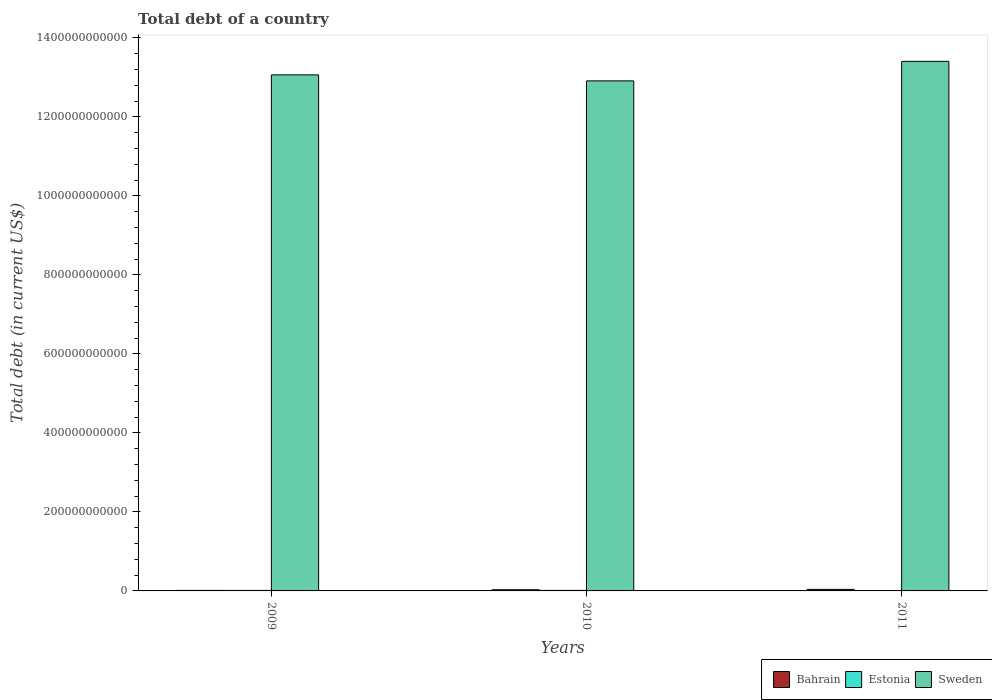How many bars are there on the 2nd tick from the right?
Provide a short and direct response. 3. What is the label of the 3rd group of bars from the left?
Ensure brevity in your answer.  2011. In how many cases, is the number of bars for a given year not equal to the number of legend labels?
Keep it short and to the point. 0. What is the debt in Sweden in 2010?
Make the answer very short. 1.29e+12. Across all years, what is the maximum debt in Estonia?
Offer a terse response. 1.31e+09. Across all years, what is the minimum debt in Estonia?
Ensure brevity in your answer.  1.08e+09. What is the total debt in Bahrain in the graph?
Give a very brief answer. 8.17e+09. What is the difference between the debt in Sweden in 2009 and that in 2011?
Ensure brevity in your answer.  -3.42e+1. What is the difference between the debt in Bahrain in 2011 and the debt in Sweden in 2009?
Keep it short and to the point. -1.30e+12. What is the average debt in Bahrain per year?
Your response must be concise. 2.72e+09. In the year 2009, what is the difference between the debt in Sweden and debt in Estonia?
Your response must be concise. 1.30e+12. In how many years, is the debt in Bahrain greater than 400000000000 US$?
Ensure brevity in your answer.  0. What is the ratio of the debt in Sweden in 2009 to that in 2011?
Ensure brevity in your answer.  0.97. Is the debt in Sweden in 2010 less than that in 2011?
Your answer should be very brief. Yes. Is the difference between the debt in Sweden in 2010 and 2011 greater than the difference between the debt in Estonia in 2010 and 2011?
Your answer should be very brief. No. What is the difference between the highest and the second highest debt in Bahrain?
Your answer should be very brief. 9.58e+08. What is the difference between the highest and the lowest debt in Bahrain?
Your answer should be compact. 2.54e+09. What does the 3rd bar from the right in 2009 represents?
Keep it short and to the point. Bahrain. How many bars are there?
Make the answer very short. 9. Are all the bars in the graph horizontal?
Provide a short and direct response. No. What is the difference between two consecutive major ticks on the Y-axis?
Keep it short and to the point. 2.00e+11. Are the values on the major ticks of Y-axis written in scientific E-notation?
Give a very brief answer. No. How are the legend labels stacked?
Offer a terse response. Horizontal. What is the title of the graph?
Your answer should be compact. Total debt of a country. Does "Uzbekistan" appear as one of the legend labels in the graph?
Offer a very short reply. No. What is the label or title of the X-axis?
Offer a terse response. Years. What is the label or title of the Y-axis?
Keep it short and to the point. Total debt (in current US$). What is the Total debt (in current US$) in Bahrain in 2009?
Your answer should be very brief. 1.35e+09. What is the Total debt (in current US$) in Estonia in 2009?
Make the answer very short. 1.25e+09. What is the Total debt (in current US$) in Sweden in 2009?
Your answer should be compact. 1.31e+12. What is the Total debt (in current US$) in Bahrain in 2010?
Keep it short and to the point. 2.93e+09. What is the Total debt (in current US$) in Estonia in 2010?
Keep it short and to the point. 1.31e+09. What is the Total debt (in current US$) in Sweden in 2010?
Your response must be concise. 1.29e+12. What is the Total debt (in current US$) of Bahrain in 2011?
Your answer should be very brief. 3.89e+09. What is the Total debt (in current US$) of Estonia in 2011?
Provide a succinct answer. 1.08e+09. What is the Total debt (in current US$) of Sweden in 2011?
Make the answer very short. 1.34e+12. Across all years, what is the maximum Total debt (in current US$) in Bahrain?
Your answer should be very brief. 3.89e+09. Across all years, what is the maximum Total debt (in current US$) in Estonia?
Your response must be concise. 1.31e+09. Across all years, what is the maximum Total debt (in current US$) in Sweden?
Provide a succinct answer. 1.34e+12. Across all years, what is the minimum Total debt (in current US$) in Bahrain?
Offer a very short reply. 1.35e+09. Across all years, what is the minimum Total debt (in current US$) in Estonia?
Make the answer very short. 1.08e+09. Across all years, what is the minimum Total debt (in current US$) in Sweden?
Provide a succinct answer. 1.29e+12. What is the total Total debt (in current US$) in Bahrain in the graph?
Provide a short and direct response. 8.17e+09. What is the total Total debt (in current US$) of Estonia in the graph?
Offer a terse response. 3.64e+09. What is the total Total debt (in current US$) of Sweden in the graph?
Keep it short and to the point. 3.94e+12. What is the difference between the Total debt (in current US$) of Bahrain in 2009 and that in 2010?
Your response must be concise. -1.58e+09. What is the difference between the Total debt (in current US$) in Estonia in 2009 and that in 2010?
Ensure brevity in your answer.  -5.88e+07. What is the difference between the Total debt (in current US$) in Sweden in 2009 and that in 2010?
Make the answer very short. 1.52e+1. What is the difference between the Total debt (in current US$) of Bahrain in 2009 and that in 2011?
Ensure brevity in your answer.  -2.54e+09. What is the difference between the Total debt (in current US$) in Estonia in 2009 and that in 2011?
Offer a very short reply. 1.74e+08. What is the difference between the Total debt (in current US$) in Sweden in 2009 and that in 2011?
Offer a terse response. -3.42e+1. What is the difference between the Total debt (in current US$) of Bahrain in 2010 and that in 2011?
Keep it short and to the point. -9.58e+08. What is the difference between the Total debt (in current US$) of Estonia in 2010 and that in 2011?
Provide a short and direct response. 2.32e+08. What is the difference between the Total debt (in current US$) of Sweden in 2010 and that in 2011?
Your response must be concise. -4.94e+1. What is the difference between the Total debt (in current US$) in Bahrain in 2009 and the Total debt (in current US$) in Estonia in 2010?
Make the answer very short. 3.88e+07. What is the difference between the Total debt (in current US$) in Bahrain in 2009 and the Total debt (in current US$) in Sweden in 2010?
Ensure brevity in your answer.  -1.29e+12. What is the difference between the Total debt (in current US$) in Estonia in 2009 and the Total debt (in current US$) in Sweden in 2010?
Your answer should be very brief. -1.29e+12. What is the difference between the Total debt (in current US$) of Bahrain in 2009 and the Total debt (in current US$) of Estonia in 2011?
Give a very brief answer. 2.71e+08. What is the difference between the Total debt (in current US$) of Bahrain in 2009 and the Total debt (in current US$) of Sweden in 2011?
Your answer should be very brief. -1.34e+12. What is the difference between the Total debt (in current US$) in Estonia in 2009 and the Total debt (in current US$) in Sweden in 2011?
Your response must be concise. -1.34e+12. What is the difference between the Total debt (in current US$) of Bahrain in 2010 and the Total debt (in current US$) of Estonia in 2011?
Offer a terse response. 1.85e+09. What is the difference between the Total debt (in current US$) in Bahrain in 2010 and the Total debt (in current US$) in Sweden in 2011?
Make the answer very short. -1.34e+12. What is the difference between the Total debt (in current US$) of Estonia in 2010 and the Total debt (in current US$) of Sweden in 2011?
Provide a short and direct response. -1.34e+12. What is the average Total debt (in current US$) in Bahrain per year?
Ensure brevity in your answer.  2.72e+09. What is the average Total debt (in current US$) of Estonia per year?
Provide a short and direct response. 1.21e+09. What is the average Total debt (in current US$) in Sweden per year?
Provide a short and direct response. 1.31e+12. In the year 2009, what is the difference between the Total debt (in current US$) in Bahrain and Total debt (in current US$) in Estonia?
Ensure brevity in your answer.  9.76e+07. In the year 2009, what is the difference between the Total debt (in current US$) of Bahrain and Total debt (in current US$) of Sweden?
Keep it short and to the point. -1.30e+12. In the year 2009, what is the difference between the Total debt (in current US$) of Estonia and Total debt (in current US$) of Sweden?
Your answer should be compact. -1.30e+12. In the year 2010, what is the difference between the Total debt (in current US$) in Bahrain and Total debt (in current US$) in Estonia?
Your answer should be very brief. 1.62e+09. In the year 2010, what is the difference between the Total debt (in current US$) of Bahrain and Total debt (in current US$) of Sweden?
Make the answer very short. -1.29e+12. In the year 2010, what is the difference between the Total debt (in current US$) of Estonia and Total debt (in current US$) of Sweden?
Keep it short and to the point. -1.29e+12. In the year 2011, what is the difference between the Total debt (in current US$) of Bahrain and Total debt (in current US$) of Estonia?
Provide a succinct answer. 2.81e+09. In the year 2011, what is the difference between the Total debt (in current US$) of Bahrain and Total debt (in current US$) of Sweden?
Keep it short and to the point. -1.34e+12. In the year 2011, what is the difference between the Total debt (in current US$) in Estonia and Total debt (in current US$) in Sweden?
Offer a very short reply. -1.34e+12. What is the ratio of the Total debt (in current US$) in Bahrain in 2009 to that in 2010?
Keep it short and to the point. 0.46. What is the ratio of the Total debt (in current US$) in Estonia in 2009 to that in 2010?
Offer a terse response. 0.96. What is the ratio of the Total debt (in current US$) of Sweden in 2009 to that in 2010?
Your answer should be very brief. 1.01. What is the ratio of the Total debt (in current US$) of Bahrain in 2009 to that in 2011?
Your answer should be compact. 0.35. What is the ratio of the Total debt (in current US$) of Estonia in 2009 to that in 2011?
Offer a very short reply. 1.16. What is the ratio of the Total debt (in current US$) in Sweden in 2009 to that in 2011?
Keep it short and to the point. 0.97. What is the ratio of the Total debt (in current US$) in Bahrain in 2010 to that in 2011?
Keep it short and to the point. 0.75. What is the ratio of the Total debt (in current US$) in Estonia in 2010 to that in 2011?
Offer a very short reply. 1.22. What is the ratio of the Total debt (in current US$) in Sweden in 2010 to that in 2011?
Provide a succinct answer. 0.96. What is the difference between the highest and the second highest Total debt (in current US$) of Bahrain?
Offer a very short reply. 9.58e+08. What is the difference between the highest and the second highest Total debt (in current US$) in Estonia?
Keep it short and to the point. 5.88e+07. What is the difference between the highest and the second highest Total debt (in current US$) in Sweden?
Ensure brevity in your answer.  3.42e+1. What is the difference between the highest and the lowest Total debt (in current US$) in Bahrain?
Give a very brief answer. 2.54e+09. What is the difference between the highest and the lowest Total debt (in current US$) of Estonia?
Provide a short and direct response. 2.32e+08. What is the difference between the highest and the lowest Total debt (in current US$) of Sweden?
Make the answer very short. 4.94e+1. 